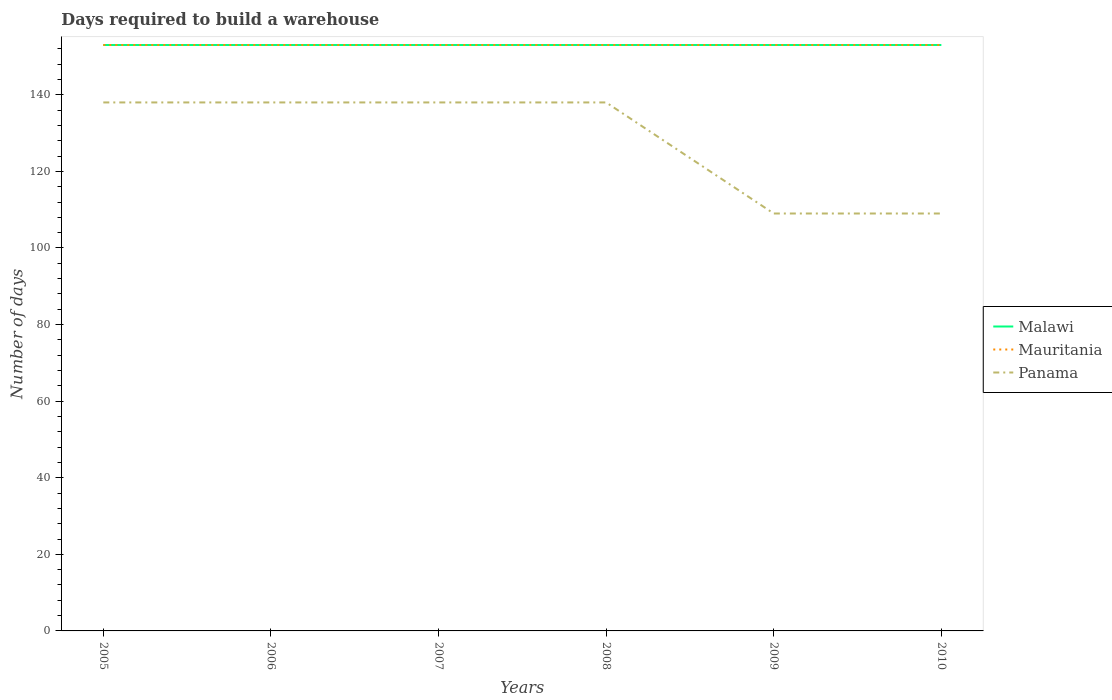How many different coloured lines are there?
Your answer should be very brief. 3. Does the line corresponding to Malawi intersect with the line corresponding to Panama?
Your answer should be very brief. No. Is the number of lines equal to the number of legend labels?
Ensure brevity in your answer.  Yes. Across all years, what is the maximum days required to build a warehouse in in Malawi?
Your answer should be very brief. 153. What is the total days required to build a warehouse in in Panama in the graph?
Your response must be concise. 29. What is the difference between the highest and the lowest days required to build a warehouse in in Panama?
Your answer should be very brief. 4. How many years are there in the graph?
Your answer should be very brief. 6. What is the difference between two consecutive major ticks on the Y-axis?
Your answer should be compact. 20. Are the values on the major ticks of Y-axis written in scientific E-notation?
Make the answer very short. No. Does the graph contain grids?
Make the answer very short. No. Where does the legend appear in the graph?
Make the answer very short. Center right. How many legend labels are there?
Provide a short and direct response. 3. How are the legend labels stacked?
Your answer should be very brief. Vertical. What is the title of the graph?
Provide a succinct answer. Days required to build a warehouse. What is the label or title of the X-axis?
Provide a short and direct response. Years. What is the label or title of the Y-axis?
Your response must be concise. Number of days. What is the Number of days of Malawi in 2005?
Your answer should be very brief. 153. What is the Number of days in Mauritania in 2005?
Make the answer very short. 153. What is the Number of days of Panama in 2005?
Keep it short and to the point. 138. What is the Number of days in Malawi in 2006?
Provide a succinct answer. 153. What is the Number of days of Mauritania in 2006?
Your answer should be very brief. 153. What is the Number of days of Panama in 2006?
Ensure brevity in your answer.  138. What is the Number of days of Malawi in 2007?
Offer a terse response. 153. What is the Number of days in Mauritania in 2007?
Offer a very short reply. 153. What is the Number of days in Panama in 2007?
Your response must be concise. 138. What is the Number of days of Malawi in 2008?
Make the answer very short. 153. What is the Number of days in Mauritania in 2008?
Keep it short and to the point. 153. What is the Number of days in Panama in 2008?
Provide a short and direct response. 138. What is the Number of days in Malawi in 2009?
Your answer should be very brief. 153. What is the Number of days in Mauritania in 2009?
Give a very brief answer. 153. What is the Number of days in Panama in 2009?
Give a very brief answer. 109. What is the Number of days of Malawi in 2010?
Offer a terse response. 153. What is the Number of days of Mauritania in 2010?
Ensure brevity in your answer.  153. What is the Number of days of Panama in 2010?
Ensure brevity in your answer.  109. Across all years, what is the maximum Number of days of Malawi?
Your answer should be very brief. 153. Across all years, what is the maximum Number of days of Mauritania?
Your answer should be compact. 153. Across all years, what is the maximum Number of days of Panama?
Keep it short and to the point. 138. Across all years, what is the minimum Number of days of Malawi?
Make the answer very short. 153. Across all years, what is the minimum Number of days in Mauritania?
Offer a very short reply. 153. Across all years, what is the minimum Number of days of Panama?
Keep it short and to the point. 109. What is the total Number of days of Malawi in the graph?
Ensure brevity in your answer.  918. What is the total Number of days of Mauritania in the graph?
Ensure brevity in your answer.  918. What is the total Number of days of Panama in the graph?
Keep it short and to the point. 770. What is the difference between the Number of days of Malawi in 2005 and that in 2006?
Offer a very short reply. 0. What is the difference between the Number of days in Mauritania in 2005 and that in 2006?
Ensure brevity in your answer.  0. What is the difference between the Number of days in Panama in 2005 and that in 2006?
Ensure brevity in your answer.  0. What is the difference between the Number of days of Malawi in 2005 and that in 2007?
Ensure brevity in your answer.  0. What is the difference between the Number of days in Panama in 2005 and that in 2007?
Give a very brief answer. 0. What is the difference between the Number of days in Mauritania in 2005 and that in 2009?
Your response must be concise. 0. What is the difference between the Number of days in Mauritania in 2005 and that in 2010?
Make the answer very short. 0. What is the difference between the Number of days of Panama in 2005 and that in 2010?
Your answer should be very brief. 29. What is the difference between the Number of days in Malawi in 2006 and that in 2007?
Offer a very short reply. 0. What is the difference between the Number of days in Panama in 2006 and that in 2007?
Give a very brief answer. 0. What is the difference between the Number of days in Malawi in 2006 and that in 2008?
Provide a succinct answer. 0. What is the difference between the Number of days in Mauritania in 2006 and that in 2008?
Give a very brief answer. 0. What is the difference between the Number of days of Mauritania in 2006 and that in 2009?
Provide a succinct answer. 0. What is the difference between the Number of days in Panama in 2006 and that in 2009?
Your response must be concise. 29. What is the difference between the Number of days of Mauritania in 2006 and that in 2010?
Offer a terse response. 0. What is the difference between the Number of days in Panama in 2006 and that in 2010?
Your answer should be compact. 29. What is the difference between the Number of days of Mauritania in 2007 and that in 2008?
Provide a succinct answer. 0. What is the difference between the Number of days of Malawi in 2007 and that in 2009?
Offer a very short reply. 0. What is the difference between the Number of days of Malawi in 2007 and that in 2010?
Your response must be concise. 0. What is the difference between the Number of days of Mauritania in 2008 and that in 2010?
Make the answer very short. 0. What is the difference between the Number of days in Panama in 2008 and that in 2010?
Your answer should be very brief. 29. What is the difference between the Number of days in Mauritania in 2009 and that in 2010?
Offer a terse response. 0. What is the difference between the Number of days of Panama in 2009 and that in 2010?
Give a very brief answer. 0. What is the difference between the Number of days of Malawi in 2005 and the Number of days of Panama in 2006?
Keep it short and to the point. 15. What is the difference between the Number of days in Malawi in 2005 and the Number of days in Mauritania in 2007?
Offer a terse response. 0. What is the difference between the Number of days of Malawi in 2005 and the Number of days of Panama in 2008?
Ensure brevity in your answer.  15. What is the difference between the Number of days of Mauritania in 2005 and the Number of days of Panama in 2008?
Provide a succinct answer. 15. What is the difference between the Number of days in Malawi in 2005 and the Number of days in Panama in 2009?
Keep it short and to the point. 44. What is the difference between the Number of days in Malawi in 2005 and the Number of days in Mauritania in 2010?
Provide a short and direct response. 0. What is the difference between the Number of days in Malawi in 2006 and the Number of days in Mauritania in 2007?
Give a very brief answer. 0. What is the difference between the Number of days in Malawi in 2006 and the Number of days in Mauritania in 2008?
Keep it short and to the point. 0. What is the difference between the Number of days in Mauritania in 2006 and the Number of days in Panama in 2008?
Give a very brief answer. 15. What is the difference between the Number of days in Malawi in 2006 and the Number of days in Panama in 2009?
Your response must be concise. 44. What is the difference between the Number of days in Mauritania in 2006 and the Number of days in Panama in 2009?
Your answer should be very brief. 44. What is the difference between the Number of days in Malawi in 2006 and the Number of days in Mauritania in 2010?
Your answer should be very brief. 0. What is the difference between the Number of days in Malawi in 2006 and the Number of days in Panama in 2010?
Your answer should be compact. 44. What is the difference between the Number of days of Malawi in 2007 and the Number of days of Panama in 2008?
Give a very brief answer. 15. What is the difference between the Number of days of Malawi in 2007 and the Number of days of Mauritania in 2009?
Your answer should be very brief. 0. What is the difference between the Number of days in Mauritania in 2007 and the Number of days in Panama in 2009?
Offer a very short reply. 44. What is the difference between the Number of days of Malawi in 2007 and the Number of days of Mauritania in 2010?
Keep it short and to the point. 0. What is the difference between the Number of days in Malawi in 2008 and the Number of days in Mauritania in 2009?
Make the answer very short. 0. What is the difference between the Number of days of Malawi in 2008 and the Number of days of Panama in 2009?
Your answer should be very brief. 44. What is the difference between the Number of days of Malawi in 2008 and the Number of days of Panama in 2010?
Ensure brevity in your answer.  44. What is the difference between the Number of days in Mauritania in 2008 and the Number of days in Panama in 2010?
Provide a succinct answer. 44. What is the difference between the Number of days of Malawi in 2009 and the Number of days of Panama in 2010?
Give a very brief answer. 44. What is the difference between the Number of days in Mauritania in 2009 and the Number of days in Panama in 2010?
Offer a very short reply. 44. What is the average Number of days in Malawi per year?
Offer a very short reply. 153. What is the average Number of days of Mauritania per year?
Provide a short and direct response. 153. What is the average Number of days in Panama per year?
Provide a short and direct response. 128.33. In the year 2005, what is the difference between the Number of days in Malawi and Number of days in Mauritania?
Your response must be concise. 0. In the year 2005, what is the difference between the Number of days in Malawi and Number of days in Panama?
Your response must be concise. 15. In the year 2006, what is the difference between the Number of days in Malawi and Number of days in Mauritania?
Give a very brief answer. 0. In the year 2006, what is the difference between the Number of days in Malawi and Number of days in Panama?
Your answer should be compact. 15. In the year 2007, what is the difference between the Number of days in Malawi and Number of days in Panama?
Offer a terse response. 15. In the year 2008, what is the difference between the Number of days of Malawi and Number of days of Mauritania?
Your response must be concise. 0. In the year 2009, what is the difference between the Number of days in Malawi and Number of days in Mauritania?
Keep it short and to the point. 0. In the year 2010, what is the difference between the Number of days in Mauritania and Number of days in Panama?
Your answer should be very brief. 44. What is the ratio of the Number of days of Mauritania in 2005 to that in 2006?
Your response must be concise. 1. What is the ratio of the Number of days in Panama in 2005 to that in 2006?
Keep it short and to the point. 1. What is the ratio of the Number of days of Malawi in 2005 to that in 2007?
Make the answer very short. 1. What is the ratio of the Number of days in Mauritania in 2005 to that in 2007?
Provide a short and direct response. 1. What is the ratio of the Number of days of Malawi in 2005 to that in 2008?
Your response must be concise. 1. What is the ratio of the Number of days in Mauritania in 2005 to that in 2008?
Keep it short and to the point. 1. What is the ratio of the Number of days of Malawi in 2005 to that in 2009?
Your response must be concise. 1. What is the ratio of the Number of days in Mauritania in 2005 to that in 2009?
Offer a terse response. 1. What is the ratio of the Number of days in Panama in 2005 to that in 2009?
Give a very brief answer. 1.27. What is the ratio of the Number of days of Panama in 2005 to that in 2010?
Your answer should be compact. 1.27. What is the ratio of the Number of days in Malawi in 2006 to that in 2007?
Provide a succinct answer. 1. What is the ratio of the Number of days in Panama in 2006 to that in 2007?
Keep it short and to the point. 1. What is the ratio of the Number of days of Malawi in 2006 to that in 2008?
Provide a short and direct response. 1. What is the ratio of the Number of days of Malawi in 2006 to that in 2009?
Ensure brevity in your answer.  1. What is the ratio of the Number of days in Panama in 2006 to that in 2009?
Your response must be concise. 1.27. What is the ratio of the Number of days in Mauritania in 2006 to that in 2010?
Offer a very short reply. 1. What is the ratio of the Number of days of Panama in 2006 to that in 2010?
Give a very brief answer. 1.27. What is the ratio of the Number of days in Mauritania in 2007 to that in 2008?
Provide a short and direct response. 1. What is the ratio of the Number of days of Panama in 2007 to that in 2008?
Provide a short and direct response. 1. What is the ratio of the Number of days of Malawi in 2007 to that in 2009?
Your response must be concise. 1. What is the ratio of the Number of days in Panama in 2007 to that in 2009?
Offer a very short reply. 1.27. What is the ratio of the Number of days in Mauritania in 2007 to that in 2010?
Give a very brief answer. 1. What is the ratio of the Number of days of Panama in 2007 to that in 2010?
Make the answer very short. 1.27. What is the ratio of the Number of days in Mauritania in 2008 to that in 2009?
Provide a succinct answer. 1. What is the ratio of the Number of days of Panama in 2008 to that in 2009?
Your answer should be compact. 1.27. What is the ratio of the Number of days of Panama in 2008 to that in 2010?
Give a very brief answer. 1.27. What is the ratio of the Number of days in Malawi in 2009 to that in 2010?
Your answer should be compact. 1. What is the ratio of the Number of days in Mauritania in 2009 to that in 2010?
Ensure brevity in your answer.  1. What is the ratio of the Number of days in Panama in 2009 to that in 2010?
Your answer should be very brief. 1. What is the difference between the highest and the second highest Number of days of Mauritania?
Offer a terse response. 0. What is the difference between the highest and the second highest Number of days in Panama?
Ensure brevity in your answer.  0. What is the difference between the highest and the lowest Number of days of Mauritania?
Offer a very short reply. 0. What is the difference between the highest and the lowest Number of days in Panama?
Offer a terse response. 29. 